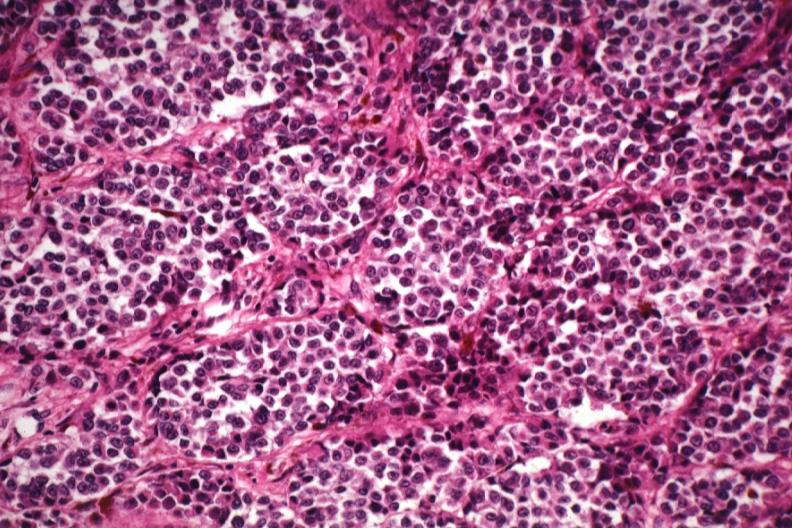s metastatic neuroblastoma present?
Answer the question using a single word or phrase. No 